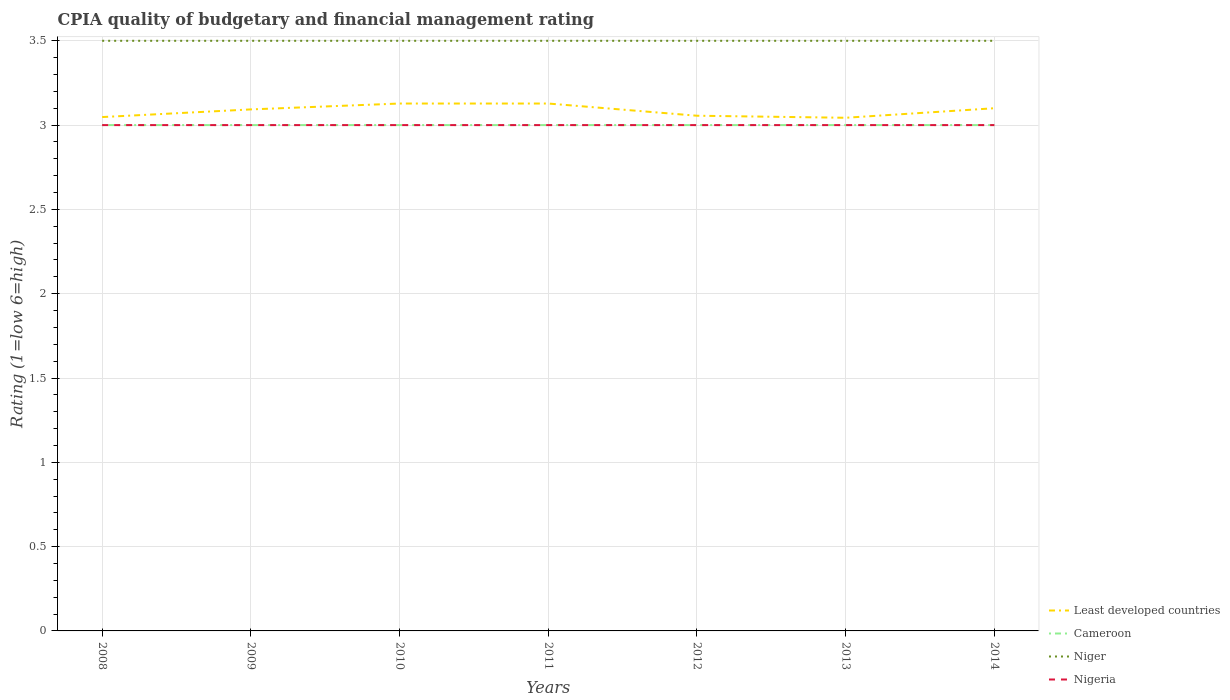Does the line corresponding to Niger intersect with the line corresponding to Cameroon?
Offer a very short reply. No. Is the number of lines equal to the number of legend labels?
Provide a succinct answer. Yes. Across all years, what is the maximum CPIA rating in Cameroon?
Give a very brief answer. 3. In which year was the CPIA rating in Nigeria maximum?
Your answer should be compact. 2008. What is the difference between the highest and the second highest CPIA rating in Least developed countries?
Make the answer very short. 0.08. How many lines are there?
Make the answer very short. 4. How many years are there in the graph?
Provide a succinct answer. 7. Are the values on the major ticks of Y-axis written in scientific E-notation?
Ensure brevity in your answer.  No. Does the graph contain grids?
Your answer should be very brief. Yes. How are the legend labels stacked?
Keep it short and to the point. Vertical. What is the title of the graph?
Your answer should be very brief. CPIA quality of budgetary and financial management rating. Does "Sub-Saharan Africa (all income levels)" appear as one of the legend labels in the graph?
Your answer should be compact. No. What is the label or title of the Y-axis?
Make the answer very short. Rating (1=low 6=high). What is the Rating (1=low 6=high) in Least developed countries in 2008?
Your response must be concise. 3.05. What is the Rating (1=low 6=high) in Niger in 2008?
Provide a succinct answer. 3.5. What is the Rating (1=low 6=high) of Nigeria in 2008?
Your answer should be very brief. 3. What is the Rating (1=low 6=high) in Least developed countries in 2009?
Give a very brief answer. 3.09. What is the Rating (1=low 6=high) of Cameroon in 2009?
Ensure brevity in your answer.  3. What is the Rating (1=low 6=high) in Nigeria in 2009?
Your answer should be very brief. 3. What is the Rating (1=low 6=high) of Least developed countries in 2010?
Your answer should be compact. 3.13. What is the Rating (1=low 6=high) of Cameroon in 2010?
Make the answer very short. 3. What is the Rating (1=low 6=high) of Niger in 2010?
Offer a very short reply. 3.5. What is the Rating (1=low 6=high) in Nigeria in 2010?
Provide a short and direct response. 3. What is the Rating (1=low 6=high) of Least developed countries in 2011?
Give a very brief answer. 3.13. What is the Rating (1=low 6=high) of Niger in 2011?
Keep it short and to the point. 3.5. What is the Rating (1=low 6=high) in Nigeria in 2011?
Your response must be concise. 3. What is the Rating (1=low 6=high) in Least developed countries in 2012?
Provide a succinct answer. 3.06. What is the Rating (1=low 6=high) of Niger in 2012?
Offer a terse response. 3.5. What is the Rating (1=low 6=high) in Least developed countries in 2013?
Make the answer very short. 3.04. What is the Rating (1=low 6=high) in Cameroon in 2013?
Provide a short and direct response. 3. What is the Rating (1=low 6=high) of Niger in 2013?
Offer a terse response. 3.5. What is the Rating (1=low 6=high) of Nigeria in 2013?
Provide a short and direct response. 3. What is the Rating (1=low 6=high) in Least developed countries in 2014?
Keep it short and to the point. 3.1. What is the Rating (1=low 6=high) in Cameroon in 2014?
Make the answer very short. 3. What is the Rating (1=low 6=high) in Niger in 2014?
Keep it short and to the point. 3.5. What is the Rating (1=low 6=high) in Nigeria in 2014?
Give a very brief answer. 3. Across all years, what is the maximum Rating (1=low 6=high) of Least developed countries?
Ensure brevity in your answer.  3.13. Across all years, what is the minimum Rating (1=low 6=high) of Least developed countries?
Offer a very short reply. 3.04. Across all years, what is the minimum Rating (1=low 6=high) in Cameroon?
Keep it short and to the point. 3. What is the total Rating (1=low 6=high) in Least developed countries in the graph?
Your response must be concise. 21.6. What is the total Rating (1=low 6=high) in Niger in the graph?
Provide a succinct answer. 24.5. What is the total Rating (1=low 6=high) in Nigeria in the graph?
Make the answer very short. 21. What is the difference between the Rating (1=low 6=high) in Least developed countries in 2008 and that in 2009?
Your answer should be compact. -0.05. What is the difference between the Rating (1=low 6=high) in Cameroon in 2008 and that in 2009?
Your answer should be very brief. 0. What is the difference between the Rating (1=low 6=high) in Least developed countries in 2008 and that in 2010?
Provide a short and direct response. -0.08. What is the difference between the Rating (1=low 6=high) in Least developed countries in 2008 and that in 2011?
Offer a very short reply. -0.08. What is the difference between the Rating (1=low 6=high) of Niger in 2008 and that in 2011?
Provide a succinct answer. 0. What is the difference between the Rating (1=low 6=high) in Nigeria in 2008 and that in 2011?
Keep it short and to the point. 0. What is the difference between the Rating (1=low 6=high) in Least developed countries in 2008 and that in 2012?
Your answer should be compact. -0.01. What is the difference between the Rating (1=low 6=high) of Nigeria in 2008 and that in 2012?
Your answer should be compact. 0. What is the difference between the Rating (1=low 6=high) in Least developed countries in 2008 and that in 2013?
Keep it short and to the point. 0. What is the difference between the Rating (1=low 6=high) in Cameroon in 2008 and that in 2013?
Keep it short and to the point. 0. What is the difference between the Rating (1=low 6=high) of Nigeria in 2008 and that in 2013?
Make the answer very short. 0. What is the difference between the Rating (1=low 6=high) in Least developed countries in 2008 and that in 2014?
Provide a succinct answer. -0.05. What is the difference between the Rating (1=low 6=high) in Cameroon in 2008 and that in 2014?
Make the answer very short. 0. What is the difference between the Rating (1=low 6=high) of Niger in 2008 and that in 2014?
Provide a succinct answer. 0. What is the difference between the Rating (1=low 6=high) of Least developed countries in 2009 and that in 2010?
Your answer should be compact. -0.03. What is the difference between the Rating (1=low 6=high) in Cameroon in 2009 and that in 2010?
Make the answer very short. 0. What is the difference between the Rating (1=low 6=high) of Least developed countries in 2009 and that in 2011?
Your response must be concise. -0.03. What is the difference between the Rating (1=low 6=high) in Cameroon in 2009 and that in 2011?
Provide a succinct answer. 0. What is the difference between the Rating (1=low 6=high) of Niger in 2009 and that in 2011?
Your answer should be compact. 0. What is the difference between the Rating (1=low 6=high) of Nigeria in 2009 and that in 2011?
Give a very brief answer. 0. What is the difference between the Rating (1=low 6=high) in Least developed countries in 2009 and that in 2012?
Make the answer very short. 0.04. What is the difference between the Rating (1=low 6=high) of Niger in 2009 and that in 2012?
Give a very brief answer. 0. What is the difference between the Rating (1=low 6=high) of Least developed countries in 2009 and that in 2013?
Provide a succinct answer. 0.05. What is the difference between the Rating (1=low 6=high) of Niger in 2009 and that in 2013?
Keep it short and to the point. 0. What is the difference between the Rating (1=low 6=high) of Nigeria in 2009 and that in 2013?
Your answer should be compact. 0. What is the difference between the Rating (1=low 6=high) in Least developed countries in 2009 and that in 2014?
Make the answer very short. -0.01. What is the difference between the Rating (1=low 6=high) of Niger in 2009 and that in 2014?
Offer a terse response. 0. What is the difference between the Rating (1=low 6=high) in Least developed countries in 2010 and that in 2011?
Provide a succinct answer. 0. What is the difference between the Rating (1=low 6=high) in Cameroon in 2010 and that in 2011?
Your response must be concise. 0. What is the difference between the Rating (1=low 6=high) in Niger in 2010 and that in 2011?
Your answer should be compact. 0. What is the difference between the Rating (1=low 6=high) in Nigeria in 2010 and that in 2011?
Your answer should be compact. 0. What is the difference between the Rating (1=low 6=high) of Least developed countries in 2010 and that in 2012?
Your answer should be very brief. 0.07. What is the difference between the Rating (1=low 6=high) of Cameroon in 2010 and that in 2012?
Provide a succinct answer. 0. What is the difference between the Rating (1=low 6=high) of Niger in 2010 and that in 2012?
Keep it short and to the point. 0. What is the difference between the Rating (1=low 6=high) in Least developed countries in 2010 and that in 2013?
Provide a short and direct response. 0.08. What is the difference between the Rating (1=low 6=high) of Cameroon in 2010 and that in 2013?
Provide a succinct answer. 0. What is the difference between the Rating (1=low 6=high) in Niger in 2010 and that in 2013?
Keep it short and to the point. 0. What is the difference between the Rating (1=low 6=high) of Nigeria in 2010 and that in 2013?
Your answer should be very brief. 0. What is the difference between the Rating (1=low 6=high) in Least developed countries in 2010 and that in 2014?
Your answer should be very brief. 0.03. What is the difference between the Rating (1=low 6=high) of Cameroon in 2010 and that in 2014?
Provide a short and direct response. 0. What is the difference between the Rating (1=low 6=high) of Nigeria in 2010 and that in 2014?
Keep it short and to the point. 0. What is the difference between the Rating (1=low 6=high) of Least developed countries in 2011 and that in 2012?
Ensure brevity in your answer.  0.07. What is the difference between the Rating (1=low 6=high) in Niger in 2011 and that in 2012?
Make the answer very short. 0. What is the difference between the Rating (1=low 6=high) in Nigeria in 2011 and that in 2012?
Make the answer very short. 0. What is the difference between the Rating (1=low 6=high) of Least developed countries in 2011 and that in 2013?
Give a very brief answer. 0.08. What is the difference between the Rating (1=low 6=high) of Cameroon in 2011 and that in 2013?
Provide a short and direct response. 0. What is the difference between the Rating (1=low 6=high) of Niger in 2011 and that in 2013?
Your answer should be compact. 0. What is the difference between the Rating (1=low 6=high) in Nigeria in 2011 and that in 2013?
Your answer should be very brief. 0. What is the difference between the Rating (1=low 6=high) of Least developed countries in 2011 and that in 2014?
Provide a short and direct response. 0.03. What is the difference between the Rating (1=low 6=high) of Niger in 2011 and that in 2014?
Your response must be concise. 0. What is the difference between the Rating (1=low 6=high) in Nigeria in 2011 and that in 2014?
Offer a very short reply. 0. What is the difference between the Rating (1=low 6=high) in Least developed countries in 2012 and that in 2013?
Offer a terse response. 0.01. What is the difference between the Rating (1=low 6=high) in Cameroon in 2012 and that in 2013?
Give a very brief answer. 0. What is the difference between the Rating (1=low 6=high) of Niger in 2012 and that in 2013?
Provide a short and direct response. 0. What is the difference between the Rating (1=low 6=high) of Least developed countries in 2012 and that in 2014?
Provide a succinct answer. -0.04. What is the difference between the Rating (1=low 6=high) in Niger in 2012 and that in 2014?
Your response must be concise. 0. What is the difference between the Rating (1=low 6=high) in Least developed countries in 2013 and that in 2014?
Give a very brief answer. -0.06. What is the difference between the Rating (1=low 6=high) in Cameroon in 2013 and that in 2014?
Offer a terse response. 0. What is the difference between the Rating (1=low 6=high) in Niger in 2013 and that in 2014?
Offer a terse response. 0. What is the difference between the Rating (1=low 6=high) in Least developed countries in 2008 and the Rating (1=low 6=high) in Cameroon in 2009?
Provide a short and direct response. 0.05. What is the difference between the Rating (1=low 6=high) of Least developed countries in 2008 and the Rating (1=low 6=high) of Niger in 2009?
Provide a succinct answer. -0.45. What is the difference between the Rating (1=low 6=high) in Least developed countries in 2008 and the Rating (1=low 6=high) in Nigeria in 2009?
Offer a terse response. 0.05. What is the difference between the Rating (1=low 6=high) in Cameroon in 2008 and the Rating (1=low 6=high) in Niger in 2009?
Offer a terse response. -0.5. What is the difference between the Rating (1=low 6=high) of Cameroon in 2008 and the Rating (1=low 6=high) of Nigeria in 2009?
Your response must be concise. 0. What is the difference between the Rating (1=low 6=high) of Niger in 2008 and the Rating (1=low 6=high) of Nigeria in 2009?
Your answer should be compact. 0.5. What is the difference between the Rating (1=low 6=high) of Least developed countries in 2008 and the Rating (1=low 6=high) of Cameroon in 2010?
Give a very brief answer. 0.05. What is the difference between the Rating (1=low 6=high) of Least developed countries in 2008 and the Rating (1=low 6=high) of Niger in 2010?
Provide a succinct answer. -0.45. What is the difference between the Rating (1=low 6=high) in Least developed countries in 2008 and the Rating (1=low 6=high) in Nigeria in 2010?
Offer a very short reply. 0.05. What is the difference between the Rating (1=low 6=high) of Cameroon in 2008 and the Rating (1=low 6=high) of Niger in 2010?
Provide a succinct answer. -0.5. What is the difference between the Rating (1=low 6=high) of Niger in 2008 and the Rating (1=low 6=high) of Nigeria in 2010?
Your answer should be compact. 0.5. What is the difference between the Rating (1=low 6=high) of Least developed countries in 2008 and the Rating (1=low 6=high) of Cameroon in 2011?
Ensure brevity in your answer.  0.05. What is the difference between the Rating (1=low 6=high) of Least developed countries in 2008 and the Rating (1=low 6=high) of Niger in 2011?
Provide a short and direct response. -0.45. What is the difference between the Rating (1=low 6=high) of Least developed countries in 2008 and the Rating (1=low 6=high) of Nigeria in 2011?
Offer a terse response. 0.05. What is the difference between the Rating (1=low 6=high) in Cameroon in 2008 and the Rating (1=low 6=high) in Niger in 2011?
Provide a succinct answer. -0.5. What is the difference between the Rating (1=low 6=high) in Cameroon in 2008 and the Rating (1=low 6=high) in Nigeria in 2011?
Keep it short and to the point. 0. What is the difference between the Rating (1=low 6=high) in Least developed countries in 2008 and the Rating (1=low 6=high) in Cameroon in 2012?
Your answer should be very brief. 0.05. What is the difference between the Rating (1=low 6=high) of Least developed countries in 2008 and the Rating (1=low 6=high) of Niger in 2012?
Keep it short and to the point. -0.45. What is the difference between the Rating (1=low 6=high) in Least developed countries in 2008 and the Rating (1=low 6=high) in Nigeria in 2012?
Your answer should be compact. 0.05. What is the difference between the Rating (1=low 6=high) of Cameroon in 2008 and the Rating (1=low 6=high) of Nigeria in 2012?
Offer a very short reply. 0. What is the difference between the Rating (1=low 6=high) in Niger in 2008 and the Rating (1=low 6=high) in Nigeria in 2012?
Ensure brevity in your answer.  0.5. What is the difference between the Rating (1=low 6=high) in Least developed countries in 2008 and the Rating (1=low 6=high) in Cameroon in 2013?
Keep it short and to the point. 0.05. What is the difference between the Rating (1=low 6=high) in Least developed countries in 2008 and the Rating (1=low 6=high) in Niger in 2013?
Keep it short and to the point. -0.45. What is the difference between the Rating (1=low 6=high) in Least developed countries in 2008 and the Rating (1=low 6=high) in Nigeria in 2013?
Provide a succinct answer. 0.05. What is the difference between the Rating (1=low 6=high) of Cameroon in 2008 and the Rating (1=low 6=high) of Nigeria in 2013?
Your answer should be compact. 0. What is the difference between the Rating (1=low 6=high) in Niger in 2008 and the Rating (1=low 6=high) in Nigeria in 2013?
Give a very brief answer. 0.5. What is the difference between the Rating (1=low 6=high) in Least developed countries in 2008 and the Rating (1=low 6=high) in Cameroon in 2014?
Keep it short and to the point. 0.05. What is the difference between the Rating (1=low 6=high) of Least developed countries in 2008 and the Rating (1=low 6=high) of Niger in 2014?
Give a very brief answer. -0.45. What is the difference between the Rating (1=low 6=high) in Least developed countries in 2008 and the Rating (1=low 6=high) in Nigeria in 2014?
Provide a short and direct response. 0.05. What is the difference between the Rating (1=low 6=high) in Cameroon in 2008 and the Rating (1=low 6=high) in Nigeria in 2014?
Ensure brevity in your answer.  0. What is the difference between the Rating (1=low 6=high) of Niger in 2008 and the Rating (1=low 6=high) of Nigeria in 2014?
Your response must be concise. 0.5. What is the difference between the Rating (1=low 6=high) of Least developed countries in 2009 and the Rating (1=low 6=high) of Cameroon in 2010?
Your response must be concise. 0.09. What is the difference between the Rating (1=low 6=high) of Least developed countries in 2009 and the Rating (1=low 6=high) of Niger in 2010?
Offer a terse response. -0.41. What is the difference between the Rating (1=low 6=high) in Least developed countries in 2009 and the Rating (1=low 6=high) in Nigeria in 2010?
Keep it short and to the point. 0.09. What is the difference between the Rating (1=low 6=high) in Cameroon in 2009 and the Rating (1=low 6=high) in Niger in 2010?
Ensure brevity in your answer.  -0.5. What is the difference between the Rating (1=low 6=high) in Cameroon in 2009 and the Rating (1=low 6=high) in Nigeria in 2010?
Give a very brief answer. 0. What is the difference between the Rating (1=low 6=high) in Niger in 2009 and the Rating (1=low 6=high) in Nigeria in 2010?
Give a very brief answer. 0.5. What is the difference between the Rating (1=low 6=high) of Least developed countries in 2009 and the Rating (1=low 6=high) of Cameroon in 2011?
Keep it short and to the point. 0.09. What is the difference between the Rating (1=low 6=high) in Least developed countries in 2009 and the Rating (1=low 6=high) in Niger in 2011?
Keep it short and to the point. -0.41. What is the difference between the Rating (1=low 6=high) of Least developed countries in 2009 and the Rating (1=low 6=high) of Nigeria in 2011?
Make the answer very short. 0.09. What is the difference between the Rating (1=low 6=high) of Cameroon in 2009 and the Rating (1=low 6=high) of Niger in 2011?
Your answer should be compact. -0.5. What is the difference between the Rating (1=low 6=high) in Cameroon in 2009 and the Rating (1=low 6=high) in Nigeria in 2011?
Provide a succinct answer. 0. What is the difference between the Rating (1=low 6=high) in Niger in 2009 and the Rating (1=low 6=high) in Nigeria in 2011?
Offer a very short reply. 0.5. What is the difference between the Rating (1=low 6=high) in Least developed countries in 2009 and the Rating (1=low 6=high) in Cameroon in 2012?
Give a very brief answer. 0.09. What is the difference between the Rating (1=low 6=high) of Least developed countries in 2009 and the Rating (1=low 6=high) of Niger in 2012?
Offer a terse response. -0.41. What is the difference between the Rating (1=low 6=high) of Least developed countries in 2009 and the Rating (1=low 6=high) of Nigeria in 2012?
Keep it short and to the point. 0.09. What is the difference between the Rating (1=low 6=high) in Cameroon in 2009 and the Rating (1=low 6=high) in Nigeria in 2012?
Provide a succinct answer. 0. What is the difference between the Rating (1=low 6=high) in Niger in 2009 and the Rating (1=low 6=high) in Nigeria in 2012?
Provide a short and direct response. 0.5. What is the difference between the Rating (1=low 6=high) in Least developed countries in 2009 and the Rating (1=low 6=high) in Cameroon in 2013?
Your answer should be compact. 0.09. What is the difference between the Rating (1=low 6=high) in Least developed countries in 2009 and the Rating (1=low 6=high) in Niger in 2013?
Offer a very short reply. -0.41. What is the difference between the Rating (1=low 6=high) of Least developed countries in 2009 and the Rating (1=low 6=high) of Nigeria in 2013?
Offer a terse response. 0.09. What is the difference between the Rating (1=low 6=high) in Least developed countries in 2009 and the Rating (1=low 6=high) in Cameroon in 2014?
Your answer should be compact. 0.09. What is the difference between the Rating (1=low 6=high) of Least developed countries in 2009 and the Rating (1=low 6=high) of Niger in 2014?
Keep it short and to the point. -0.41. What is the difference between the Rating (1=low 6=high) of Least developed countries in 2009 and the Rating (1=low 6=high) of Nigeria in 2014?
Provide a succinct answer. 0.09. What is the difference between the Rating (1=low 6=high) in Cameroon in 2009 and the Rating (1=low 6=high) in Niger in 2014?
Give a very brief answer. -0.5. What is the difference between the Rating (1=low 6=high) of Cameroon in 2009 and the Rating (1=low 6=high) of Nigeria in 2014?
Your answer should be very brief. 0. What is the difference between the Rating (1=low 6=high) in Niger in 2009 and the Rating (1=low 6=high) in Nigeria in 2014?
Make the answer very short. 0.5. What is the difference between the Rating (1=low 6=high) of Least developed countries in 2010 and the Rating (1=low 6=high) of Cameroon in 2011?
Offer a very short reply. 0.13. What is the difference between the Rating (1=low 6=high) in Least developed countries in 2010 and the Rating (1=low 6=high) in Niger in 2011?
Keep it short and to the point. -0.37. What is the difference between the Rating (1=low 6=high) in Least developed countries in 2010 and the Rating (1=low 6=high) in Nigeria in 2011?
Your response must be concise. 0.13. What is the difference between the Rating (1=low 6=high) in Cameroon in 2010 and the Rating (1=low 6=high) in Niger in 2011?
Offer a very short reply. -0.5. What is the difference between the Rating (1=low 6=high) in Cameroon in 2010 and the Rating (1=low 6=high) in Nigeria in 2011?
Give a very brief answer. 0. What is the difference between the Rating (1=low 6=high) of Least developed countries in 2010 and the Rating (1=low 6=high) of Cameroon in 2012?
Give a very brief answer. 0.13. What is the difference between the Rating (1=low 6=high) in Least developed countries in 2010 and the Rating (1=low 6=high) in Niger in 2012?
Offer a terse response. -0.37. What is the difference between the Rating (1=low 6=high) in Least developed countries in 2010 and the Rating (1=low 6=high) in Nigeria in 2012?
Provide a short and direct response. 0.13. What is the difference between the Rating (1=low 6=high) of Least developed countries in 2010 and the Rating (1=low 6=high) of Cameroon in 2013?
Keep it short and to the point. 0.13. What is the difference between the Rating (1=low 6=high) of Least developed countries in 2010 and the Rating (1=low 6=high) of Niger in 2013?
Your answer should be very brief. -0.37. What is the difference between the Rating (1=low 6=high) in Least developed countries in 2010 and the Rating (1=low 6=high) in Nigeria in 2013?
Provide a short and direct response. 0.13. What is the difference between the Rating (1=low 6=high) of Cameroon in 2010 and the Rating (1=low 6=high) of Nigeria in 2013?
Ensure brevity in your answer.  0. What is the difference between the Rating (1=low 6=high) in Least developed countries in 2010 and the Rating (1=low 6=high) in Cameroon in 2014?
Keep it short and to the point. 0.13. What is the difference between the Rating (1=low 6=high) in Least developed countries in 2010 and the Rating (1=low 6=high) in Niger in 2014?
Offer a very short reply. -0.37. What is the difference between the Rating (1=low 6=high) of Least developed countries in 2010 and the Rating (1=low 6=high) of Nigeria in 2014?
Make the answer very short. 0.13. What is the difference between the Rating (1=low 6=high) of Cameroon in 2010 and the Rating (1=low 6=high) of Niger in 2014?
Offer a terse response. -0.5. What is the difference between the Rating (1=low 6=high) of Niger in 2010 and the Rating (1=low 6=high) of Nigeria in 2014?
Give a very brief answer. 0.5. What is the difference between the Rating (1=low 6=high) in Least developed countries in 2011 and the Rating (1=low 6=high) in Cameroon in 2012?
Your answer should be compact. 0.13. What is the difference between the Rating (1=low 6=high) of Least developed countries in 2011 and the Rating (1=low 6=high) of Niger in 2012?
Give a very brief answer. -0.37. What is the difference between the Rating (1=low 6=high) in Least developed countries in 2011 and the Rating (1=low 6=high) in Nigeria in 2012?
Offer a terse response. 0.13. What is the difference between the Rating (1=low 6=high) of Cameroon in 2011 and the Rating (1=low 6=high) of Niger in 2012?
Provide a short and direct response. -0.5. What is the difference between the Rating (1=low 6=high) of Cameroon in 2011 and the Rating (1=low 6=high) of Nigeria in 2012?
Ensure brevity in your answer.  0. What is the difference between the Rating (1=low 6=high) in Niger in 2011 and the Rating (1=low 6=high) in Nigeria in 2012?
Give a very brief answer. 0.5. What is the difference between the Rating (1=low 6=high) in Least developed countries in 2011 and the Rating (1=low 6=high) in Cameroon in 2013?
Your response must be concise. 0.13. What is the difference between the Rating (1=low 6=high) in Least developed countries in 2011 and the Rating (1=low 6=high) in Niger in 2013?
Make the answer very short. -0.37. What is the difference between the Rating (1=low 6=high) in Least developed countries in 2011 and the Rating (1=low 6=high) in Nigeria in 2013?
Provide a short and direct response. 0.13. What is the difference between the Rating (1=low 6=high) in Cameroon in 2011 and the Rating (1=low 6=high) in Nigeria in 2013?
Your response must be concise. 0. What is the difference between the Rating (1=low 6=high) in Niger in 2011 and the Rating (1=low 6=high) in Nigeria in 2013?
Your answer should be compact. 0.5. What is the difference between the Rating (1=low 6=high) of Least developed countries in 2011 and the Rating (1=low 6=high) of Cameroon in 2014?
Provide a succinct answer. 0.13. What is the difference between the Rating (1=low 6=high) in Least developed countries in 2011 and the Rating (1=low 6=high) in Niger in 2014?
Make the answer very short. -0.37. What is the difference between the Rating (1=low 6=high) of Least developed countries in 2011 and the Rating (1=low 6=high) of Nigeria in 2014?
Your response must be concise. 0.13. What is the difference between the Rating (1=low 6=high) in Cameroon in 2011 and the Rating (1=low 6=high) in Niger in 2014?
Keep it short and to the point. -0.5. What is the difference between the Rating (1=low 6=high) of Cameroon in 2011 and the Rating (1=low 6=high) of Nigeria in 2014?
Provide a short and direct response. 0. What is the difference between the Rating (1=low 6=high) of Least developed countries in 2012 and the Rating (1=low 6=high) of Cameroon in 2013?
Your response must be concise. 0.06. What is the difference between the Rating (1=low 6=high) in Least developed countries in 2012 and the Rating (1=low 6=high) in Niger in 2013?
Provide a short and direct response. -0.44. What is the difference between the Rating (1=low 6=high) of Least developed countries in 2012 and the Rating (1=low 6=high) of Nigeria in 2013?
Provide a succinct answer. 0.06. What is the difference between the Rating (1=low 6=high) in Cameroon in 2012 and the Rating (1=low 6=high) in Niger in 2013?
Provide a succinct answer. -0.5. What is the difference between the Rating (1=low 6=high) in Cameroon in 2012 and the Rating (1=low 6=high) in Nigeria in 2013?
Offer a terse response. 0. What is the difference between the Rating (1=low 6=high) in Niger in 2012 and the Rating (1=low 6=high) in Nigeria in 2013?
Provide a succinct answer. 0.5. What is the difference between the Rating (1=low 6=high) in Least developed countries in 2012 and the Rating (1=low 6=high) in Cameroon in 2014?
Offer a terse response. 0.06. What is the difference between the Rating (1=low 6=high) in Least developed countries in 2012 and the Rating (1=low 6=high) in Niger in 2014?
Offer a terse response. -0.44. What is the difference between the Rating (1=low 6=high) of Least developed countries in 2012 and the Rating (1=low 6=high) of Nigeria in 2014?
Offer a very short reply. 0.06. What is the difference between the Rating (1=low 6=high) of Least developed countries in 2013 and the Rating (1=low 6=high) of Cameroon in 2014?
Keep it short and to the point. 0.04. What is the difference between the Rating (1=low 6=high) of Least developed countries in 2013 and the Rating (1=low 6=high) of Niger in 2014?
Your answer should be compact. -0.46. What is the difference between the Rating (1=low 6=high) in Least developed countries in 2013 and the Rating (1=low 6=high) in Nigeria in 2014?
Your answer should be compact. 0.04. What is the difference between the Rating (1=low 6=high) of Cameroon in 2013 and the Rating (1=low 6=high) of Niger in 2014?
Offer a terse response. -0.5. What is the difference between the Rating (1=low 6=high) of Cameroon in 2013 and the Rating (1=low 6=high) of Nigeria in 2014?
Your answer should be very brief. 0. What is the average Rating (1=low 6=high) of Least developed countries per year?
Give a very brief answer. 3.09. What is the average Rating (1=low 6=high) of Cameroon per year?
Give a very brief answer. 3. What is the average Rating (1=low 6=high) in Niger per year?
Ensure brevity in your answer.  3.5. What is the average Rating (1=low 6=high) in Nigeria per year?
Provide a succinct answer. 3. In the year 2008, what is the difference between the Rating (1=low 6=high) in Least developed countries and Rating (1=low 6=high) in Cameroon?
Provide a succinct answer. 0.05. In the year 2008, what is the difference between the Rating (1=low 6=high) of Least developed countries and Rating (1=low 6=high) of Niger?
Make the answer very short. -0.45. In the year 2008, what is the difference between the Rating (1=low 6=high) of Least developed countries and Rating (1=low 6=high) of Nigeria?
Provide a short and direct response. 0.05. In the year 2008, what is the difference between the Rating (1=low 6=high) in Cameroon and Rating (1=low 6=high) in Niger?
Offer a terse response. -0.5. In the year 2009, what is the difference between the Rating (1=low 6=high) in Least developed countries and Rating (1=low 6=high) in Cameroon?
Your answer should be compact. 0.09. In the year 2009, what is the difference between the Rating (1=low 6=high) in Least developed countries and Rating (1=low 6=high) in Niger?
Provide a succinct answer. -0.41. In the year 2009, what is the difference between the Rating (1=low 6=high) of Least developed countries and Rating (1=low 6=high) of Nigeria?
Offer a very short reply. 0.09. In the year 2010, what is the difference between the Rating (1=low 6=high) of Least developed countries and Rating (1=low 6=high) of Cameroon?
Your response must be concise. 0.13. In the year 2010, what is the difference between the Rating (1=low 6=high) in Least developed countries and Rating (1=low 6=high) in Niger?
Provide a short and direct response. -0.37. In the year 2010, what is the difference between the Rating (1=low 6=high) of Least developed countries and Rating (1=low 6=high) of Nigeria?
Give a very brief answer. 0.13. In the year 2010, what is the difference between the Rating (1=low 6=high) of Cameroon and Rating (1=low 6=high) of Niger?
Ensure brevity in your answer.  -0.5. In the year 2010, what is the difference between the Rating (1=low 6=high) in Cameroon and Rating (1=low 6=high) in Nigeria?
Provide a succinct answer. 0. In the year 2010, what is the difference between the Rating (1=low 6=high) of Niger and Rating (1=low 6=high) of Nigeria?
Keep it short and to the point. 0.5. In the year 2011, what is the difference between the Rating (1=low 6=high) of Least developed countries and Rating (1=low 6=high) of Cameroon?
Give a very brief answer. 0.13. In the year 2011, what is the difference between the Rating (1=low 6=high) of Least developed countries and Rating (1=low 6=high) of Niger?
Your answer should be very brief. -0.37. In the year 2011, what is the difference between the Rating (1=low 6=high) in Least developed countries and Rating (1=low 6=high) in Nigeria?
Offer a very short reply. 0.13. In the year 2012, what is the difference between the Rating (1=low 6=high) of Least developed countries and Rating (1=low 6=high) of Cameroon?
Keep it short and to the point. 0.06. In the year 2012, what is the difference between the Rating (1=low 6=high) in Least developed countries and Rating (1=low 6=high) in Niger?
Offer a very short reply. -0.44. In the year 2012, what is the difference between the Rating (1=low 6=high) in Least developed countries and Rating (1=low 6=high) in Nigeria?
Offer a very short reply. 0.06. In the year 2013, what is the difference between the Rating (1=low 6=high) of Least developed countries and Rating (1=low 6=high) of Cameroon?
Your response must be concise. 0.04. In the year 2013, what is the difference between the Rating (1=low 6=high) in Least developed countries and Rating (1=low 6=high) in Niger?
Offer a very short reply. -0.46. In the year 2013, what is the difference between the Rating (1=low 6=high) of Least developed countries and Rating (1=low 6=high) of Nigeria?
Provide a succinct answer. 0.04. In the year 2013, what is the difference between the Rating (1=low 6=high) in Cameroon and Rating (1=low 6=high) in Niger?
Give a very brief answer. -0.5. In the year 2013, what is the difference between the Rating (1=low 6=high) of Cameroon and Rating (1=low 6=high) of Nigeria?
Your answer should be very brief. 0. In the year 2014, what is the difference between the Rating (1=low 6=high) in Least developed countries and Rating (1=low 6=high) in Niger?
Your answer should be very brief. -0.4. In the year 2014, what is the difference between the Rating (1=low 6=high) of Least developed countries and Rating (1=low 6=high) of Nigeria?
Keep it short and to the point. 0.1. In the year 2014, what is the difference between the Rating (1=low 6=high) in Cameroon and Rating (1=low 6=high) in Niger?
Make the answer very short. -0.5. What is the ratio of the Rating (1=low 6=high) of Least developed countries in 2008 to that in 2009?
Ensure brevity in your answer.  0.99. What is the ratio of the Rating (1=low 6=high) of Cameroon in 2008 to that in 2009?
Ensure brevity in your answer.  1. What is the ratio of the Rating (1=low 6=high) in Niger in 2008 to that in 2009?
Offer a terse response. 1. What is the ratio of the Rating (1=low 6=high) of Nigeria in 2008 to that in 2009?
Your answer should be compact. 1. What is the ratio of the Rating (1=low 6=high) of Least developed countries in 2008 to that in 2010?
Make the answer very short. 0.97. What is the ratio of the Rating (1=low 6=high) of Nigeria in 2008 to that in 2010?
Your answer should be compact. 1. What is the ratio of the Rating (1=low 6=high) of Least developed countries in 2008 to that in 2011?
Your answer should be very brief. 0.97. What is the ratio of the Rating (1=low 6=high) of Cameroon in 2008 to that in 2011?
Give a very brief answer. 1. What is the ratio of the Rating (1=low 6=high) of Niger in 2008 to that in 2011?
Provide a short and direct response. 1. What is the ratio of the Rating (1=low 6=high) of Nigeria in 2008 to that in 2011?
Offer a very short reply. 1. What is the ratio of the Rating (1=low 6=high) of Least developed countries in 2008 to that in 2012?
Your answer should be compact. 1. What is the ratio of the Rating (1=low 6=high) in Niger in 2008 to that in 2012?
Offer a very short reply. 1. What is the ratio of the Rating (1=low 6=high) in Least developed countries in 2008 to that in 2013?
Offer a very short reply. 1. What is the ratio of the Rating (1=low 6=high) in Niger in 2008 to that in 2013?
Offer a terse response. 1. What is the ratio of the Rating (1=low 6=high) in Nigeria in 2008 to that in 2013?
Give a very brief answer. 1. What is the ratio of the Rating (1=low 6=high) in Least developed countries in 2008 to that in 2014?
Provide a succinct answer. 0.98. What is the ratio of the Rating (1=low 6=high) of Cameroon in 2008 to that in 2014?
Your answer should be compact. 1. What is the ratio of the Rating (1=low 6=high) of Nigeria in 2008 to that in 2014?
Provide a short and direct response. 1. What is the ratio of the Rating (1=low 6=high) in Cameroon in 2009 to that in 2010?
Offer a very short reply. 1. What is the ratio of the Rating (1=low 6=high) in Niger in 2009 to that in 2010?
Provide a short and direct response. 1. What is the ratio of the Rating (1=low 6=high) in Least developed countries in 2009 to that in 2011?
Offer a terse response. 0.99. What is the ratio of the Rating (1=low 6=high) of Cameroon in 2009 to that in 2011?
Make the answer very short. 1. What is the ratio of the Rating (1=low 6=high) in Niger in 2009 to that in 2011?
Offer a very short reply. 1. What is the ratio of the Rating (1=low 6=high) in Nigeria in 2009 to that in 2011?
Keep it short and to the point. 1. What is the ratio of the Rating (1=low 6=high) of Least developed countries in 2009 to that in 2012?
Offer a terse response. 1.01. What is the ratio of the Rating (1=low 6=high) of Niger in 2009 to that in 2012?
Ensure brevity in your answer.  1. What is the ratio of the Rating (1=low 6=high) of Nigeria in 2009 to that in 2012?
Provide a short and direct response. 1. What is the ratio of the Rating (1=low 6=high) of Least developed countries in 2009 to that in 2013?
Offer a terse response. 1.02. What is the ratio of the Rating (1=low 6=high) of Cameroon in 2009 to that in 2013?
Your answer should be compact. 1. What is the ratio of the Rating (1=low 6=high) in Niger in 2009 to that in 2014?
Offer a very short reply. 1. What is the ratio of the Rating (1=low 6=high) of Nigeria in 2010 to that in 2011?
Offer a very short reply. 1. What is the ratio of the Rating (1=low 6=high) in Least developed countries in 2010 to that in 2012?
Make the answer very short. 1.02. What is the ratio of the Rating (1=low 6=high) in Niger in 2010 to that in 2012?
Provide a short and direct response. 1. What is the ratio of the Rating (1=low 6=high) in Nigeria in 2010 to that in 2012?
Offer a terse response. 1. What is the ratio of the Rating (1=low 6=high) in Least developed countries in 2010 to that in 2013?
Ensure brevity in your answer.  1.03. What is the ratio of the Rating (1=low 6=high) in Cameroon in 2010 to that in 2013?
Make the answer very short. 1. What is the ratio of the Rating (1=low 6=high) in Niger in 2010 to that in 2013?
Make the answer very short. 1. What is the ratio of the Rating (1=low 6=high) of Least developed countries in 2011 to that in 2012?
Keep it short and to the point. 1.02. What is the ratio of the Rating (1=low 6=high) of Niger in 2011 to that in 2012?
Give a very brief answer. 1. What is the ratio of the Rating (1=low 6=high) in Least developed countries in 2011 to that in 2013?
Your response must be concise. 1.03. What is the ratio of the Rating (1=low 6=high) in Cameroon in 2011 to that in 2013?
Ensure brevity in your answer.  1. What is the ratio of the Rating (1=low 6=high) of Niger in 2011 to that in 2013?
Ensure brevity in your answer.  1. What is the ratio of the Rating (1=low 6=high) of Niger in 2011 to that in 2014?
Your answer should be compact. 1. What is the ratio of the Rating (1=low 6=high) in Nigeria in 2011 to that in 2014?
Make the answer very short. 1. What is the ratio of the Rating (1=low 6=high) of Least developed countries in 2012 to that in 2013?
Provide a succinct answer. 1. What is the ratio of the Rating (1=low 6=high) of Cameroon in 2012 to that in 2013?
Your answer should be very brief. 1. What is the ratio of the Rating (1=low 6=high) of Least developed countries in 2012 to that in 2014?
Your response must be concise. 0.99. What is the ratio of the Rating (1=low 6=high) of Niger in 2012 to that in 2014?
Offer a terse response. 1. What is the ratio of the Rating (1=low 6=high) in Nigeria in 2012 to that in 2014?
Provide a short and direct response. 1. What is the ratio of the Rating (1=low 6=high) in Least developed countries in 2013 to that in 2014?
Provide a succinct answer. 0.98. What is the ratio of the Rating (1=low 6=high) in Cameroon in 2013 to that in 2014?
Make the answer very short. 1. What is the ratio of the Rating (1=low 6=high) of Nigeria in 2013 to that in 2014?
Make the answer very short. 1. What is the difference between the highest and the second highest Rating (1=low 6=high) in Least developed countries?
Provide a succinct answer. 0. What is the difference between the highest and the second highest Rating (1=low 6=high) in Niger?
Your answer should be compact. 0. What is the difference between the highest and the second highest Rating (1=low 6=high) in Nigeria?
Ensure brevity in your answer.  0. What is the difference between the highest and the lowest Rating (1=low 6=high) of Least developed countries?
Your answer should be compact. 0.08. What is the difference between the highest and the lowest Rating (1=low 6=high) of Nigeria?
Offer a very short reply. 0. 